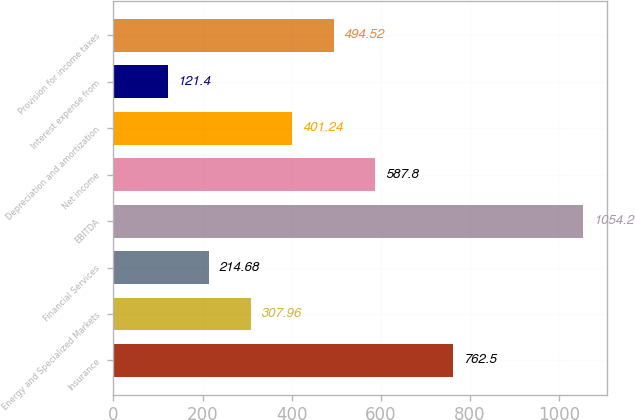Convert chart. <chart><loc_0><loc_0><loc_500><loc_500><bar_chart><fcel>Insurance<fcel>Energy and Specialized Markets<fcel>Financial Services<fcel>EBITDA<fcel>Net income<fcel>Depreciation and amortization<fcel>Interest expense from<fcel>Provision for income taxes<nl><fcel>762.5<fcel>307.96<fcel>214.68<fcel>1054.2<fcel>587.8<fcel>401.24<fcel>121.4<fcel>494.52<nl></chart> 